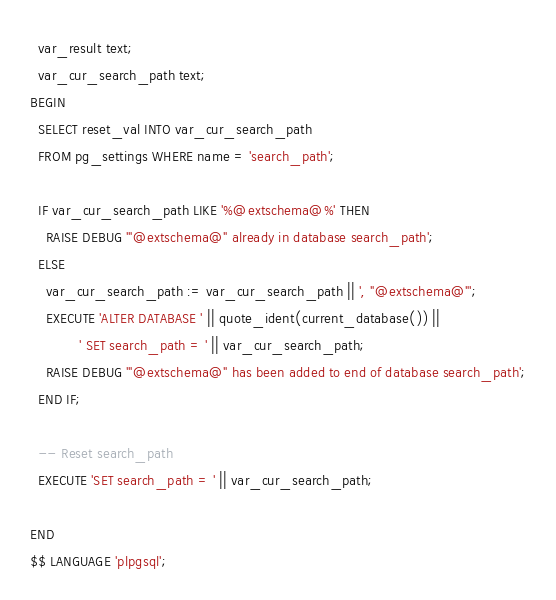<code> <loc_0><loc_0><loc_500><loc_500><_SQL_>  var_result text;
  var_cur_search_path text;
BEGIN
  SELECT reset_val INTO var_cur_search_path
  FROM pg_settings WHERE name = 'search_path';

  IF var_cur_search_path LIKE '%@extschema@%' THEN
    RAISE DEBUG '"@extschema@" already in database search_path';
  ELSE
    var_cur_search_path := var_cur_search_path || ', "@extschema@"';
    EXECUTE 'ALTER DATABASE ' || quote_ident(current_database()) ||
            ' SET search_path = ' || var_cur_search_path;
    RAISE DEBUG '"@extschema@" has been added to end of database search_path';
  END IF;

  -- Reset search_path
  EXECUTE 'SET search_path = ' || var_cur_search_path;

END
$$ LANGUAGE 'plpgsql';
</code> 